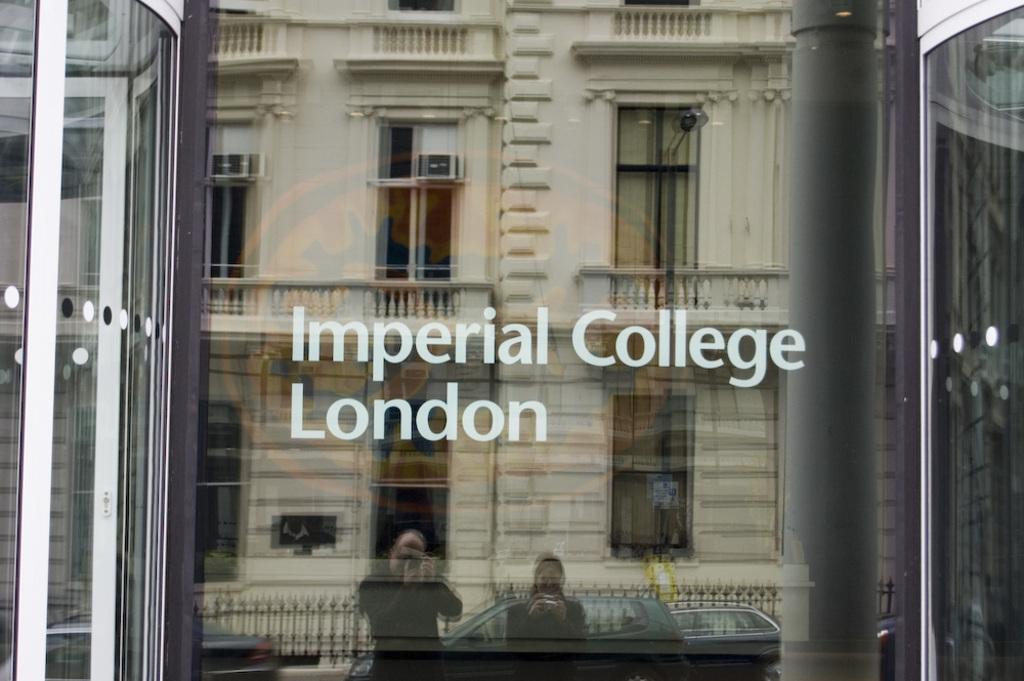Please provide a concise description of this image. In this picture we can see a glass door. On the glass door we can see the text and reflection of a building, windows, grilles, cars and two people are standing and holding the cameras. 